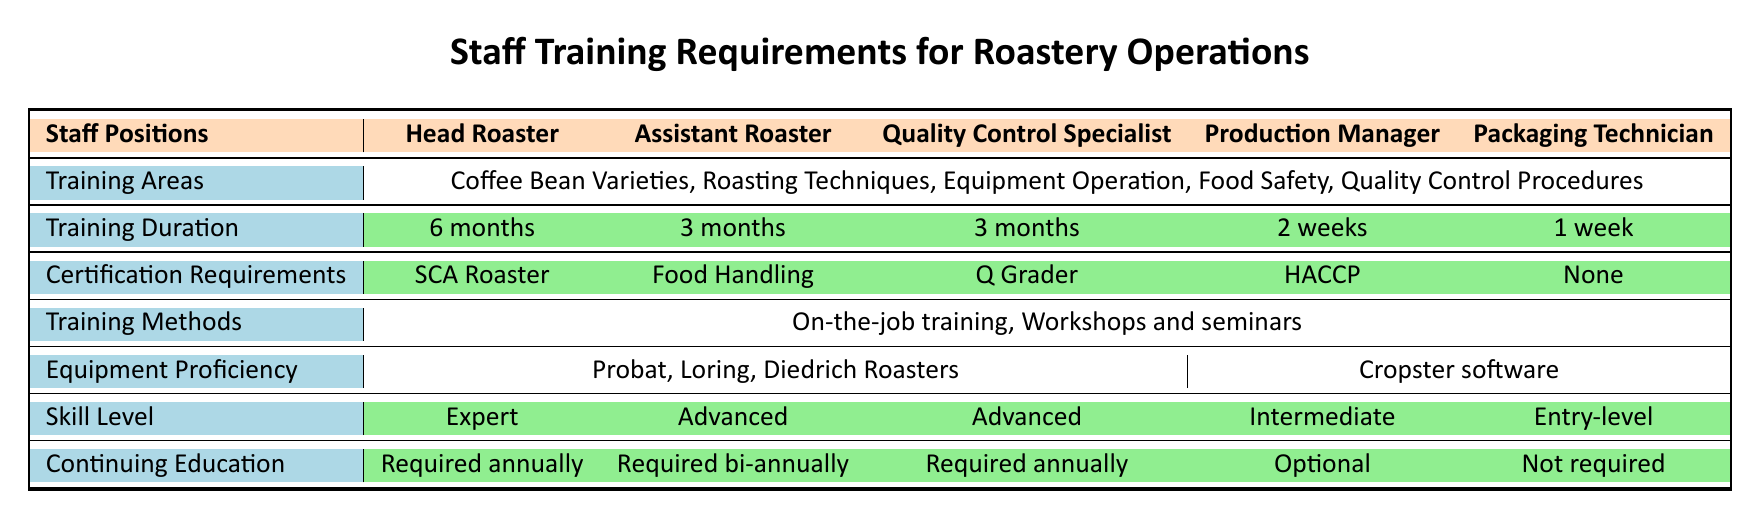What is the training duration for the Head Roaster? The table specifies the training duration for the Head Roaster in the corresponding column, which is listed as 6 months.
Answer: 6 months Which staff position requires a Food Handling Certificate? Looking at the certification requirements, the Assistant Roaster is the only position that lists the Food Handling Certificate as a requirement.
Answer: Assistant Roaster How many months of training does the Production Manager undergo? By checking the training duration for the Production Manager in the table, it shows a training duration of 2 weeks.
Answer: 2 weeks Is the Quality Control Specialist's continuing education required annually? The table indicates that the Quality Control Specialist must continue education annually, as shown in the continuing education row of that specific position.
Answer: Yes List one training method used for all staff positions. The table shows that "On-the-job training" is listed as a training method for all staff positions.
Answer: On-the-job training What is the average training duration for all staff positions in months? The training durations for each position are: Head Roaster (6 months), Assistant Roaster (0.5 months), Quality Control Specialist (0.5 months), Production Manager (0.5 months), and Packaging Technician (1 month). Adding these values gives a total of 8 months and dividing by 5 positions results in an average of 1.6 months.
Answer: 1.6 months Which staff position requires the highest skill level? The skill levels for the positions are: Head Roaster (Expert), Assistant Roaster (Advanced), Quality Control Specialist (Advanced), Production Manager (Intermediate), and Packaging Technician (Entry-level). The Head Roaster position requires the highest skill level of Expert.
Answer: Head Roaster Does the Packaging Technician require any certification? The table explicitly lists "None" under certification requirements for the Packaging Technician, indicating that there are no certification requirements for this position.
Answer: Yes How many positions have an ongoing education requirement? The potentially ongoing education requirements are for the Head Roaster, Quality Control Specialist, and Assistant Roaster. Summing these gives a total of 3 positions with that requirement.
Answer: 3 positions 